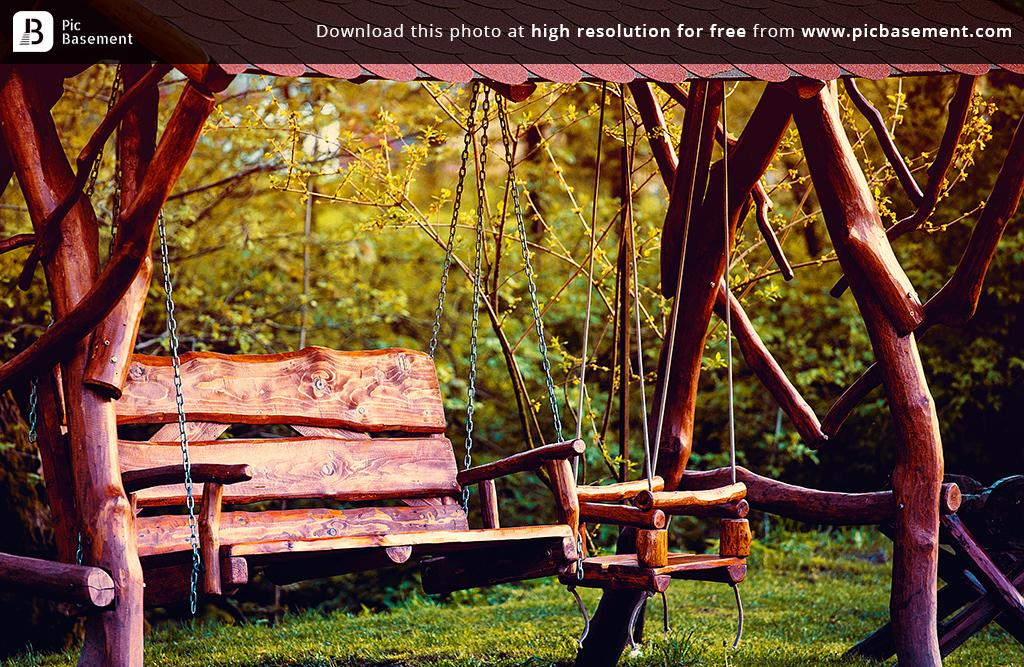What type of seating is present in the image? There are wooden benches in the image. How are the benches connected to another object? The benches are attached to an object with chains. What can be seen in the background of the image? There are trees and grass visible in the background of the image. What type of property does the woman own in the image? There is no woman or property present in the image; it only features wooden benches, chains, trees, and grass. 